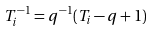<formula> <loc_0><loc_0><loc_500><loc_500>T _ { i } ^ { - 1 } = q ^ { - 1 } ( T _ { i } - q + 1 )</formula> 